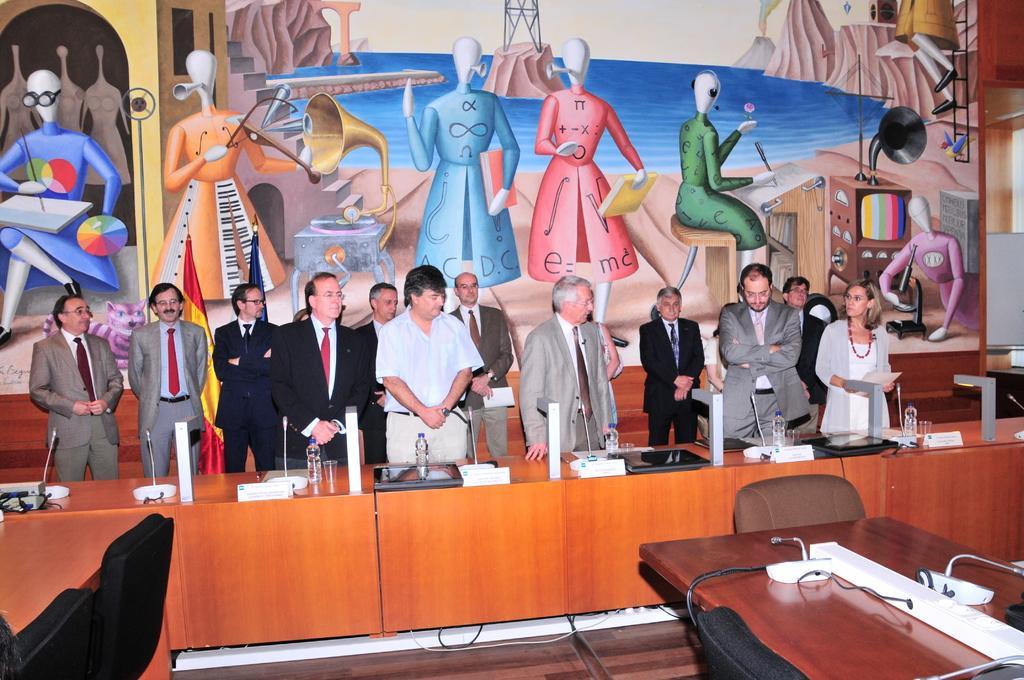Can you describe this image briefly? In this picture there is a man who is wearing white shirt and trouser. He is standing near to the man who is wearing black suit. On the right there is a woman who is wearing spectacle, jacket, t-shirt, locket and holding a book. Beside her we can see two person standing near the table. On the table we can see mics, water bottles, water glasses, tray, laptops, papers, tables and other objects. In the background we can see the painted wall. At the bottom right we can see the chairs and table. 